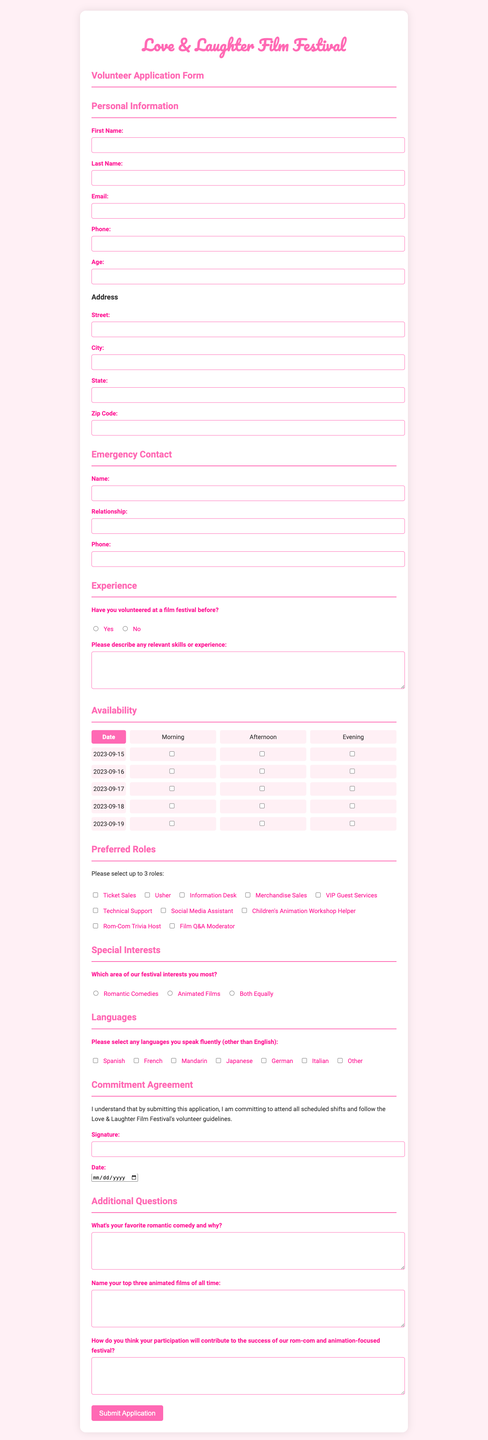what is the name of the festival? The festival name is stated at the top of the document in the header.
Answer: Love & Laughter Film Festival what is the date of the first availability? The first availability date is listed in the availability section of the document.
Answer: 2023-09-15 how many preferred roles can a volunteer select? The maximum number of selections for preferred roles is provided in the preferred roles section.
Answer: 3 what languages can a volunteer choose from? The languages section provides a list of languages that can be selected.
Answer: Spanish, French, Mandarin, Japanese, German, Italian, Other what is the question regarding previous volunteer experience? The document includes a specific question related to previous volunteer experience in the experience section.
Answer: Have you volunteered at a film festival before? what is the required age format for applicants? The age input section specifies the data type expected from volunteers applying.
Answer: Number what is the commitment agreement statement? The commitment agreement statement is outlined in a specific section of the document.
Answer: I understand that by submitting this application, I am committing to attend all scheduled shifts and follow the Love & Laughter Film Festival's volunteer guidelines how many dates are available for volunteering? The document lists specific dates available in the availability section.
Answer: 5 which area of the festival interests the volunteer the most? There is a specific question asking volunteers about their area of interest.
Answer: Which area of our festival interests you most? 